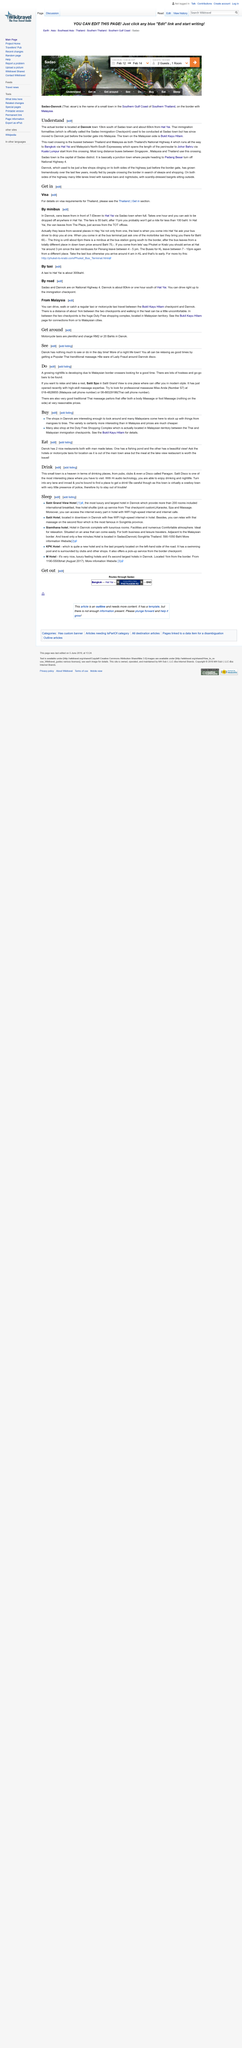Indicate a few pertinent items in this graphic. The road crossing located at Dannok town is the busiest between Thailand and Malaysia, as it is a commonly used border crossing between the two countries. Sadao town is the capital of Sadao district, and it is the place where the district's government is located. Yes, Thailand's National Highway 4 runs all the way to Bangkok. 